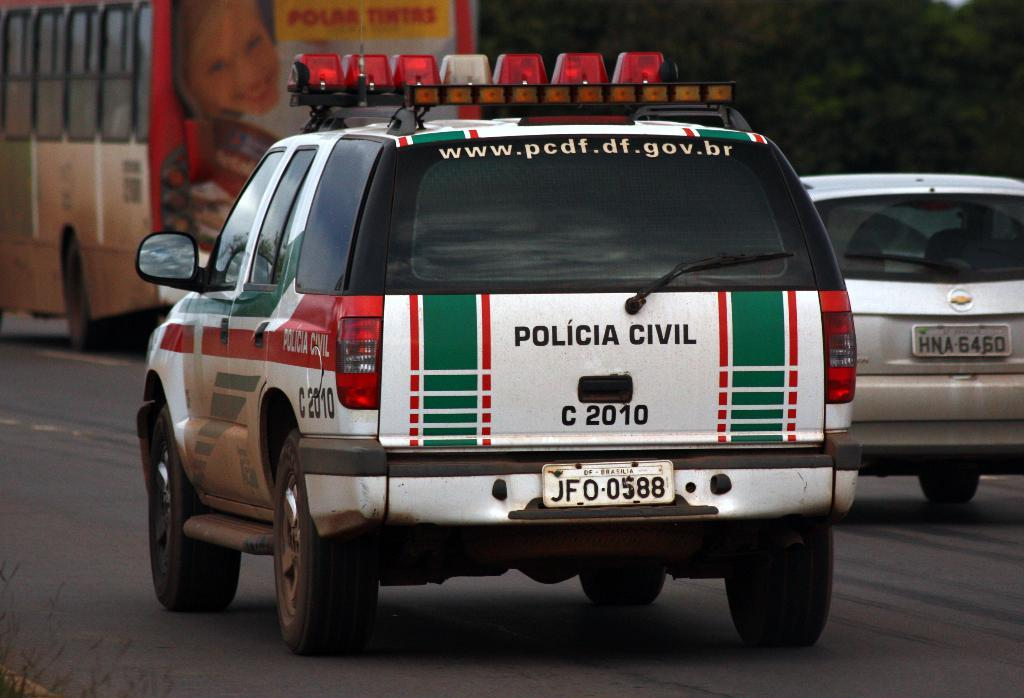What can be seen on the road in the image? There are vehicles on the road in the image. What type of natural scenery is visible in the background of the image? There are trees visible in the background of the image. What type of wool is being used to make a connection between the trees in the image? There is no wool or connection between the trees in the image; it only features vehicles on the road and trees in the background. 